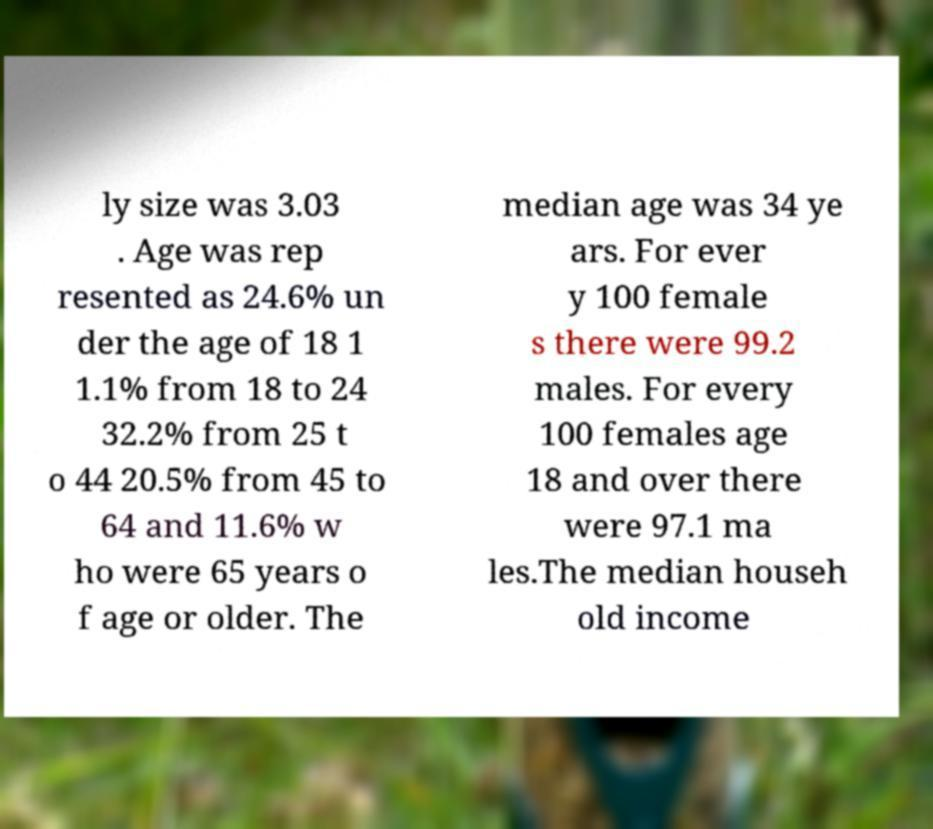What messages or text are displayed in this image? I need them in a readable, typed format. ly size was 3.03 . Age was rep resented as 24.6% un der the age of 18 1 1.1% from 18 to 24 32.2% from 25 t o 44 20.5% from 45 to 64 and 11.6% w ho were 65 years o f age or older. The median age was 34 ye ars. For ever y 100 female s there were 99.2 males. For every 100 females age 18 and over there were 97.1 ma les.The median househ old income 